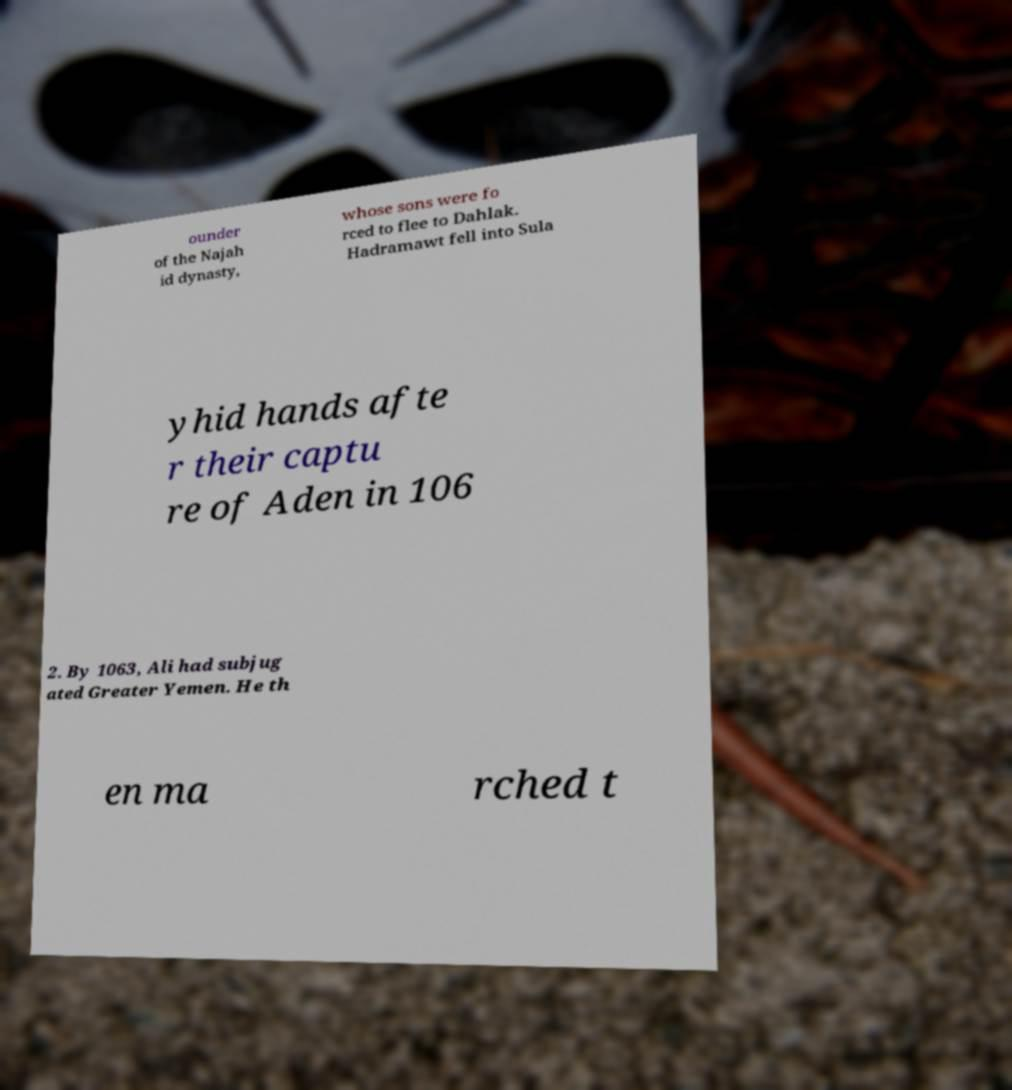Please identify and transcribe the text found in this image. ounder of the Najah id dynasty, whose sons were fo rced to flee to Dahlak. Hadramawt fell into Sula yhid hands afte r their captu re of Aden in 106 2. By 1063, Ali had subjug ated Greater Yemen. He th en ma rched t 